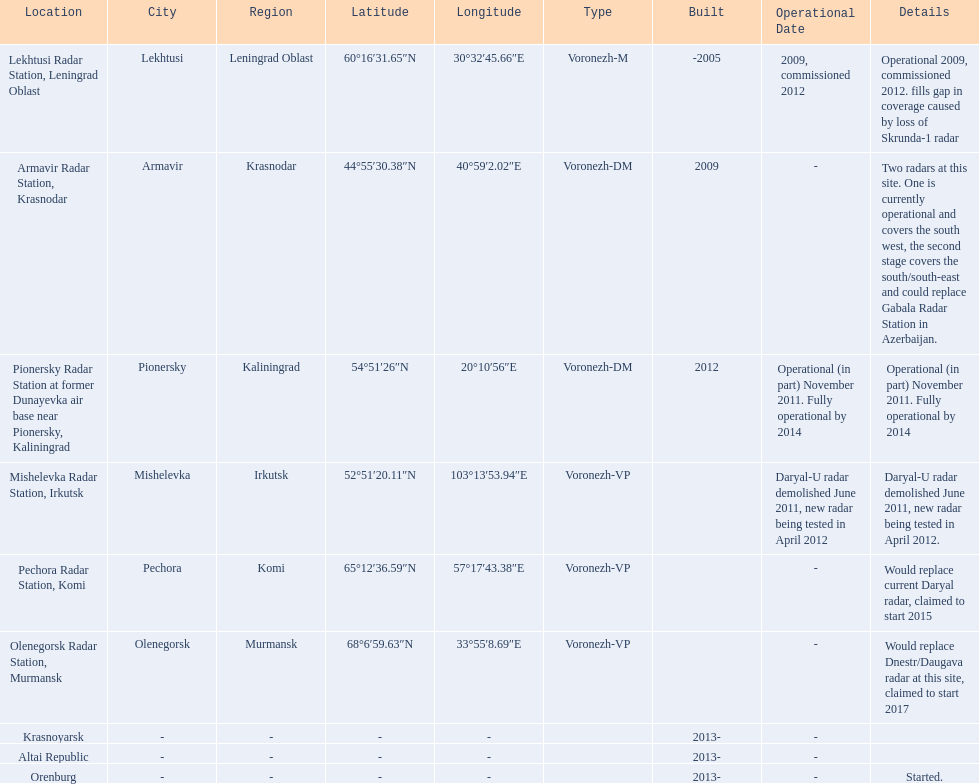What are all of the locations? Lekhtusi Radar Station, Leningrad Oblast, Armavir Radar Station, Krasnodar, Pionersky Radar Station at former Dunayevka air base near Pionersky, Kaliningrad, Mishelevka Radar Station, Irkutsk, Pechora Radar Station, Komi, Olenegorsk Radar Station, Murmansk, Krasnoyarsk, Altai Republic, Orenburg. And which location's coordinates are 60deg16'31.65''n 30deg32'45.66''e / 60.2754583degn 30.5460167dege? Lekhtusi Radar Station, Leningrad Oblast. 